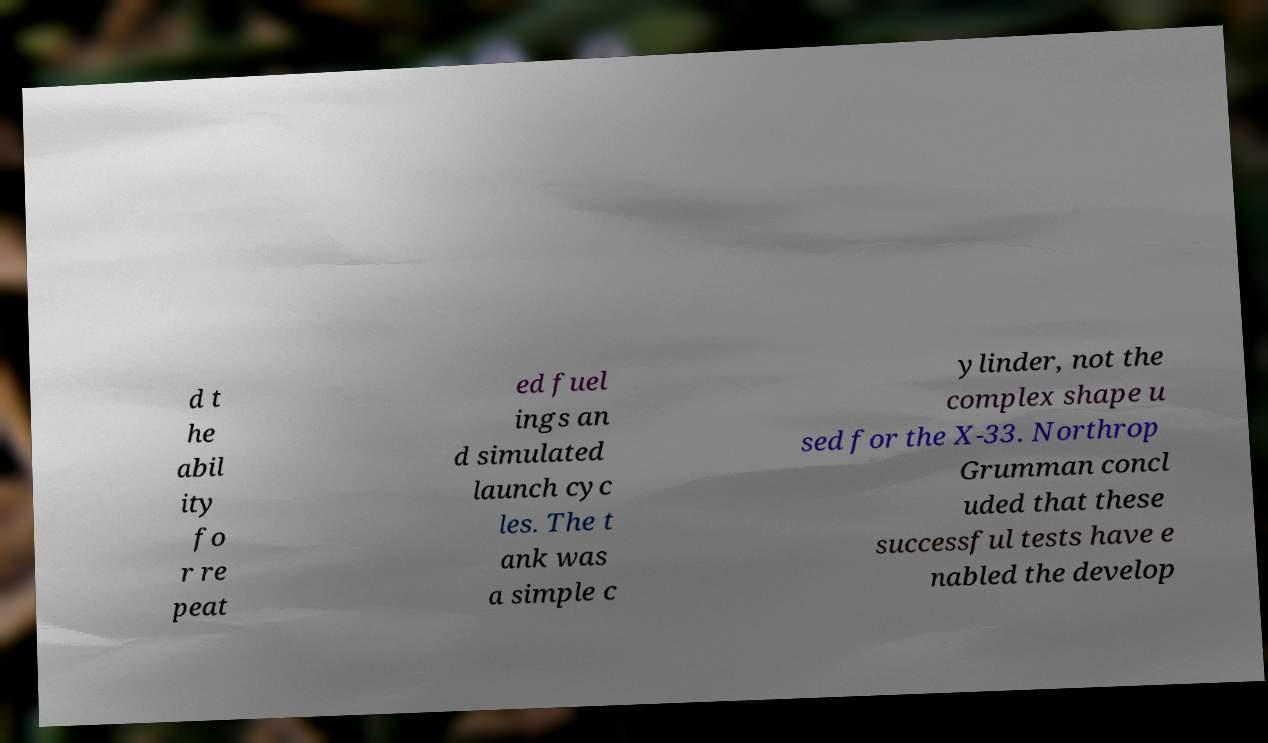Can you accurately transcribe the text from the provided image for me? d t he abil ity fo r re peat ed fuel ings an d simulated launch cyc les. The t ank was a simple c ylinder, not the complex shape u sed for the X-33. Northrop Grumman concl uded that these successful tests have e nabled the develop 